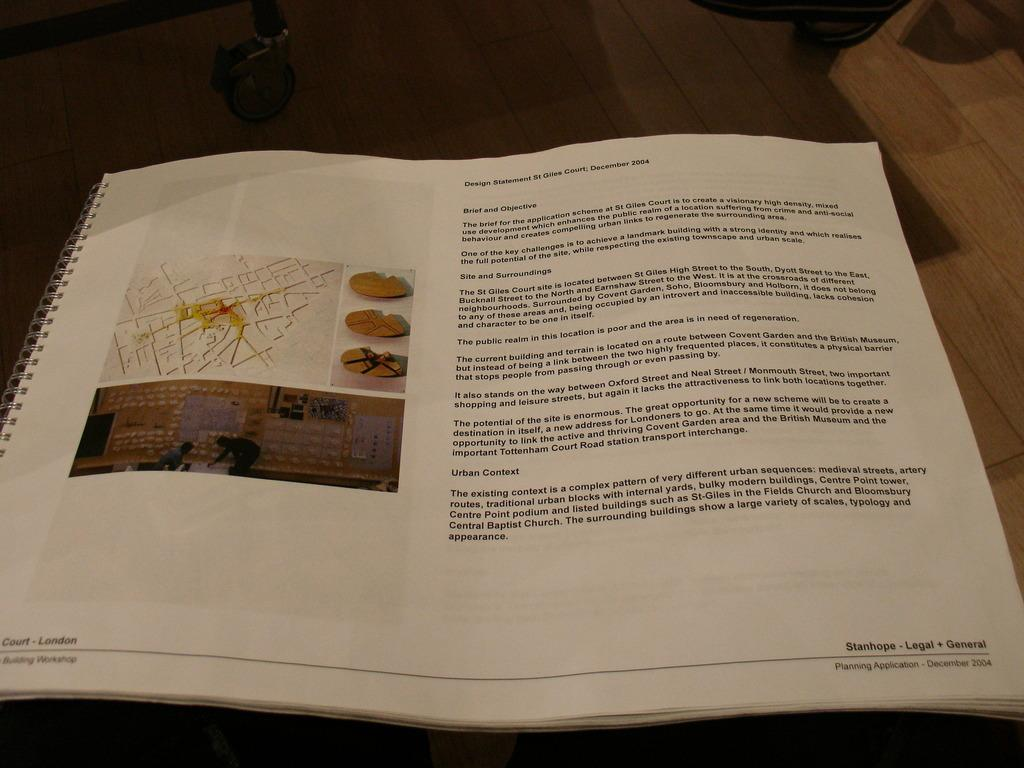<image>
Present a compact description of the photo's key features. a book that says 'stanhope-legal + general' on it 